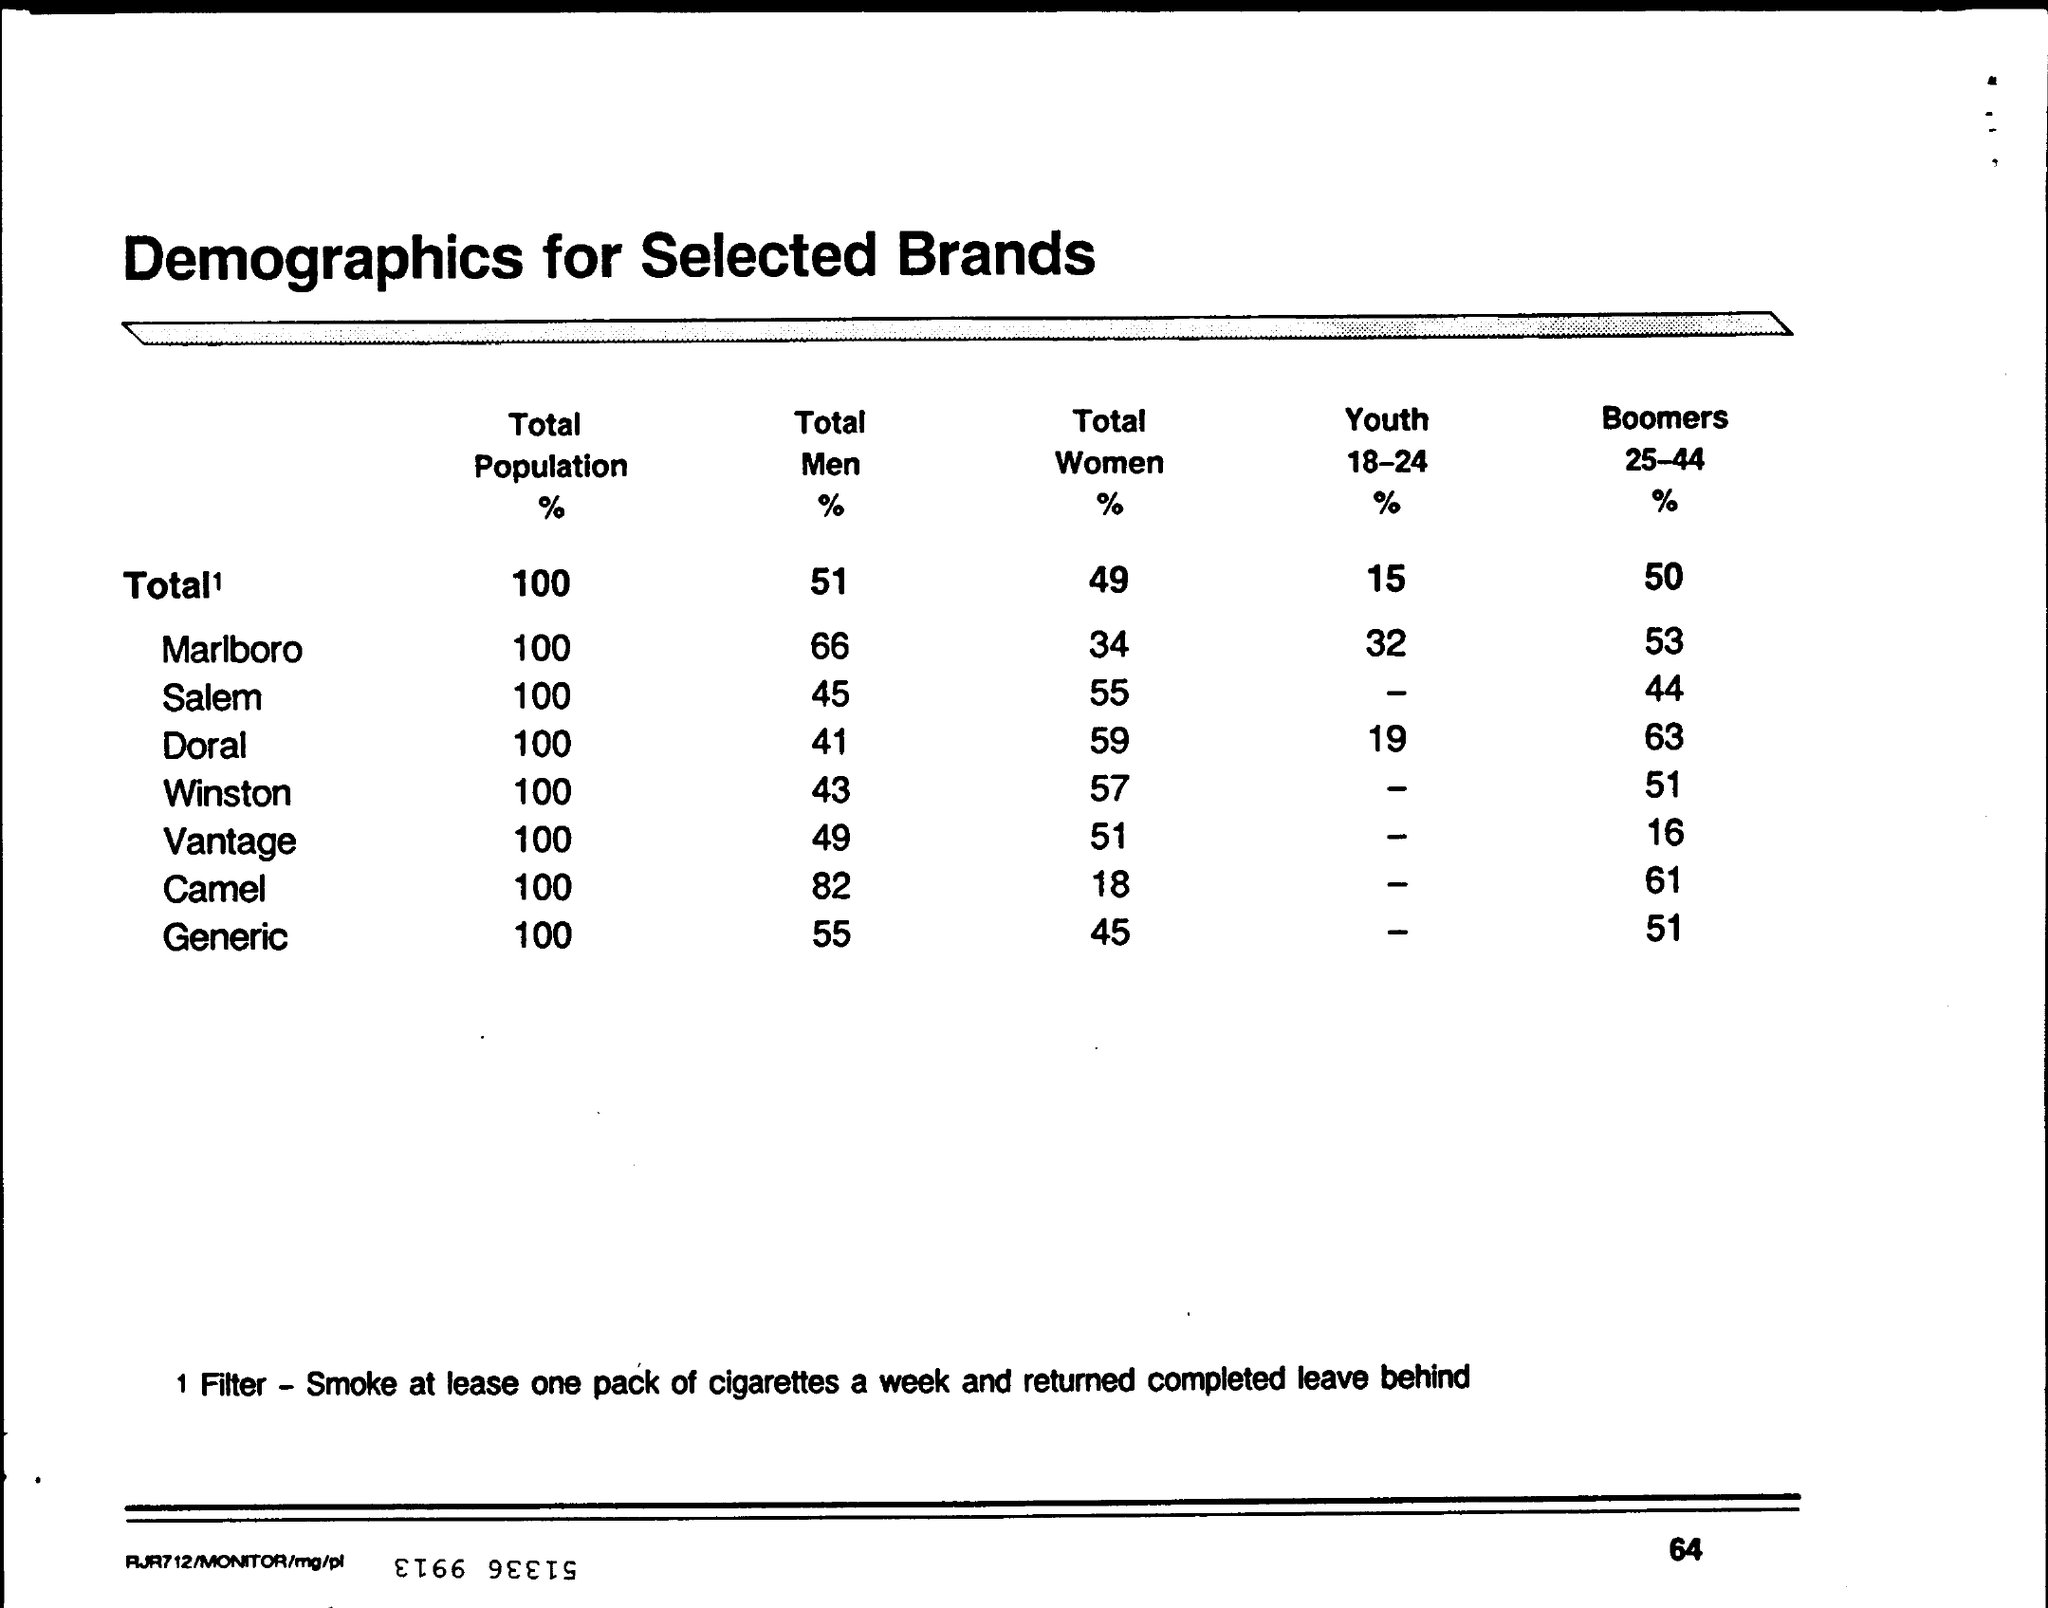List a handful of essential elements in this visual. The total men percentage for Winston is 43%. The total percentage of men in Salem is 45%. The total percentage of women for Winston is 57%. The total percentage of women in Doral is 59%. The total percentage of women at Vantage is 51%. 